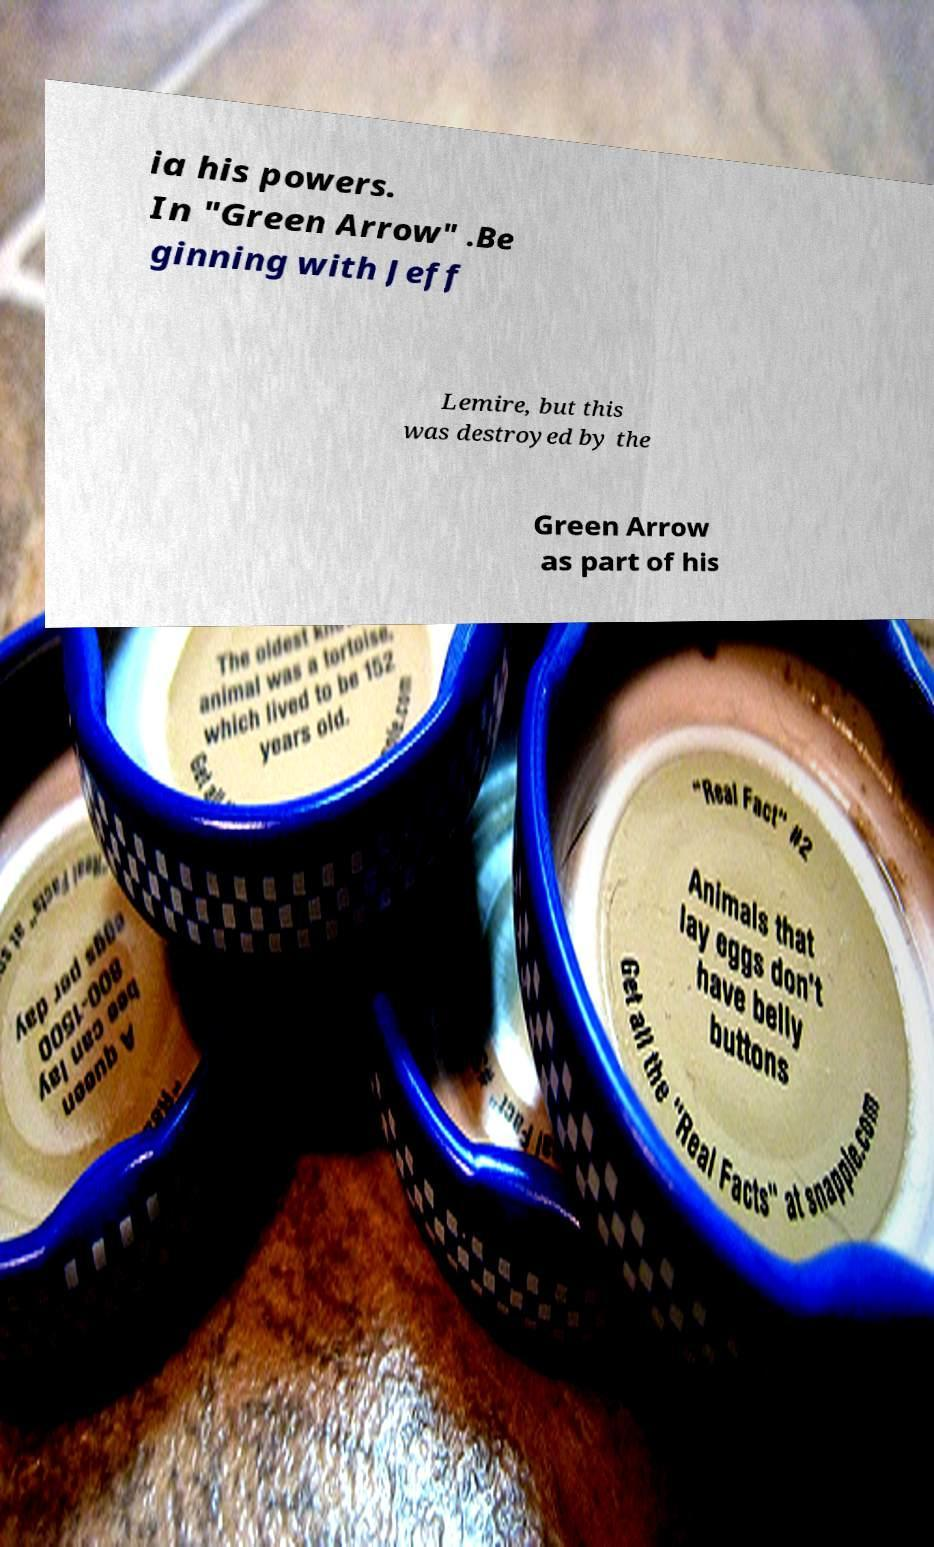Can you accurately transcribe the text from the provided image for me? ia his powers. In "Green Arrow" .Be ginning with Jeff Lemire, but this was destroyed by the Green Arrow as part of his 